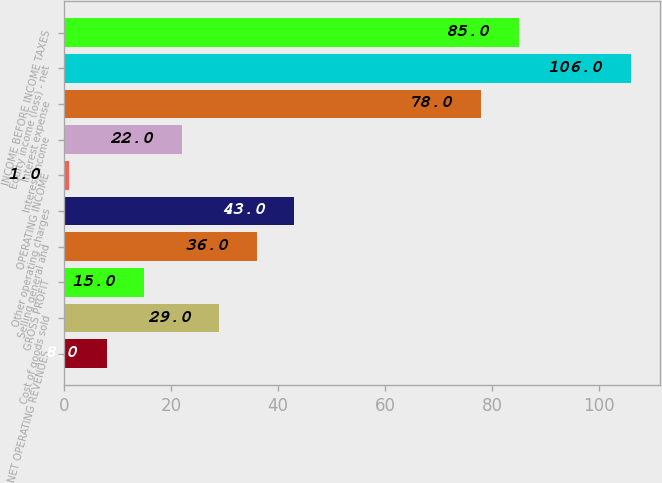<chart> <loc_0><loc_0><loc_500><loc_500><bar_chart><fcel>NET OPERATING REVENUES<fcel>Cost of goods sold<fcel>GROSS PROFIT<fcel>Selling general and<fcel>Other operating charges<fcel>OPERATING INCOME<fcel>Interest income<fcel>Interest expense<fcel>Equity income (loss) - net<fcel>INCOME BEFORE INCOME TAXES<nl><fcel>8<fcel>29<fcel>15<fcel>36<fcel>43<fcel>1<fcel>22<fcel>78<fcel>106<fcel>85<nl></chart> 